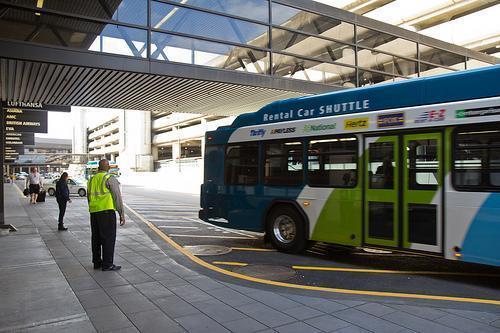How many people are there?
Give a very brief answer. 3. How many buses are there?
Give a very brief answer. 1. How many tires can you see?
Give a very brief answer. 1. 